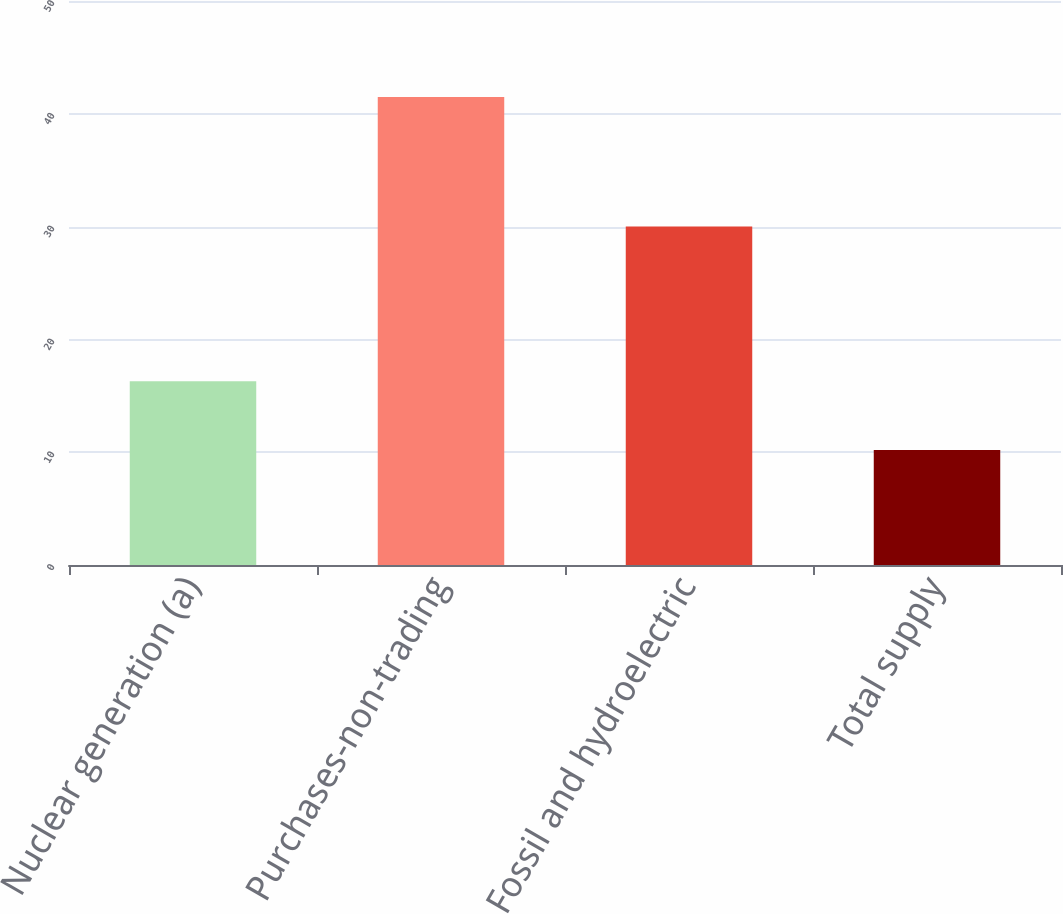Convert chart to OTSL. <chart><loc_0><loc_0><loc_500><loc_500><bar_chart><fcel>Nuclear generation (a)<fcel>Purchases-non-trading<fcel>Fossil and hydroelectric<fcel>Total supply<nl><fcel>16.3<fcel>41.5<fcel>30<fcel>10.2<nl></chart> 